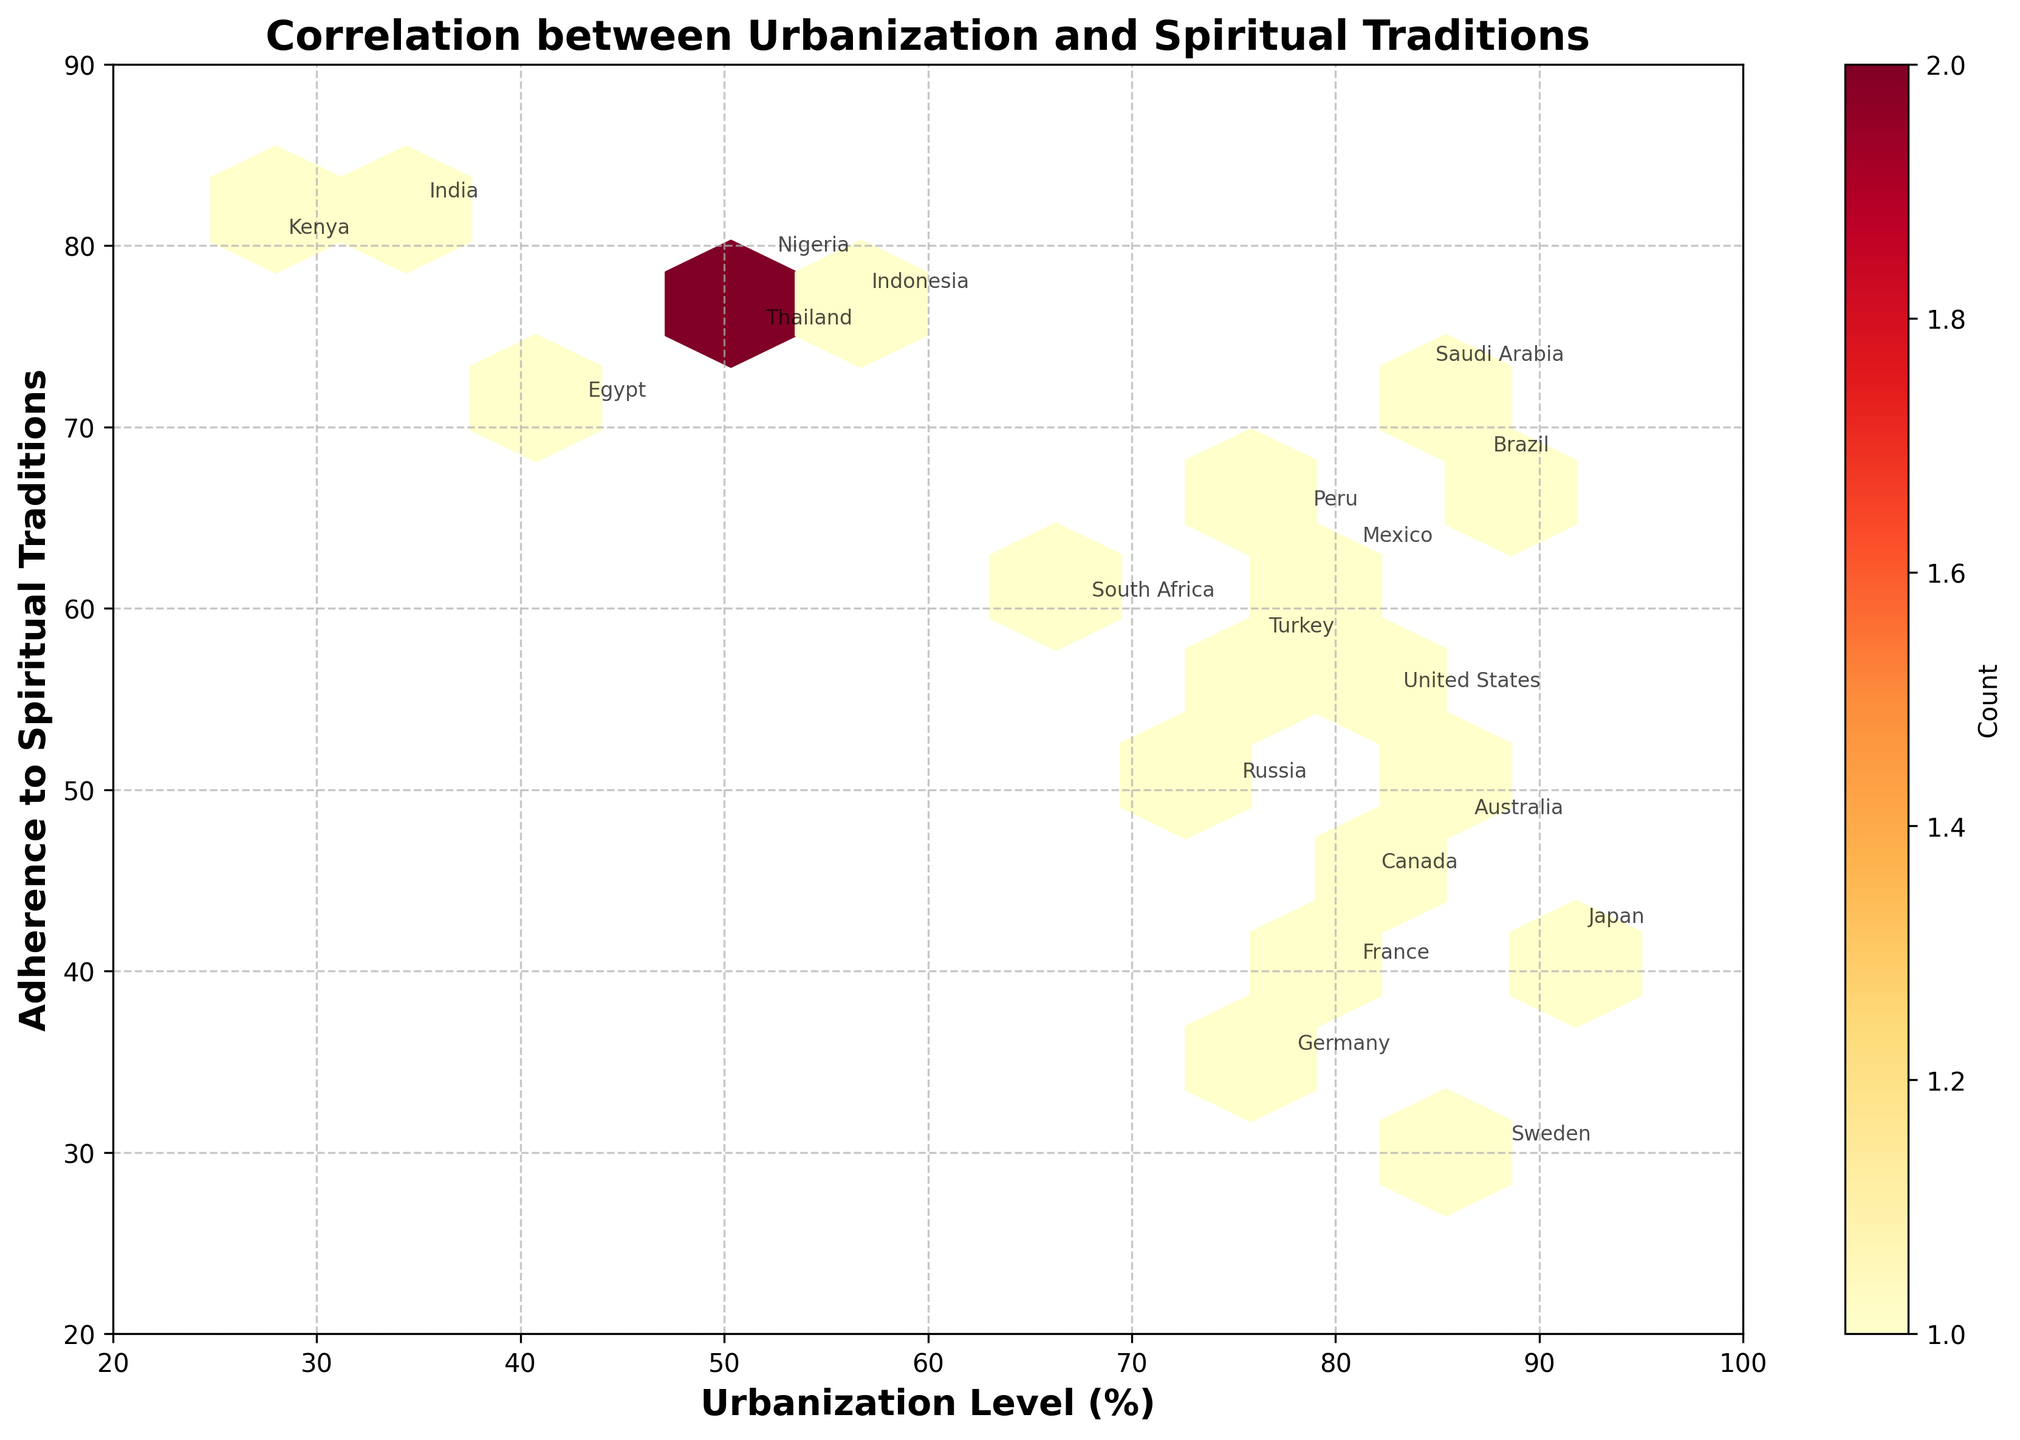What is the title of the figure? The title can be found at the top of the figure.
Answer: Correlation between Urbanization and Spiritual Traditions What are the axes labels? The labels are usually found next to the axes. The x-axis label is at the bottom and the y-axis label is to the left.
Answer: Urbanization Level (%) and Adherence to Spiritual Traditions Which country has the highest adherence to spiritual traditions? By examining the highest value on the y-axis (Adherence to Spiritual Traditions) and looking for the country annotation at that point.
Answer: India What is the range of urbanization levels presented in the figure? The x-axis starts from 20 to 100, representing the range of urbanization levels shown in the figure.
Answer: 20% to 100% How many countries have urbanization levels above 80%? By looking at the x-axis and counting the annotated countries above 80% mark.
Answer: 11 What is the trend between urbanization levels and adherence to spiritual traditions in the plot? By observing the general direction or pattern of the hexagons, one can see if there is an increase or decrease in adherence to spiritual traditions as urbanization levels change.
Answer: Negative correlation Which country represents outliers in adherence to spiritual traditions versus urbanization level, if any? Outliers can be identified by their significant deviation from the general trend or by isolated locations in the plot.
Answer: Kenya (high adherence but low urbanization) How does the clustering of hexagons help in analyzing patterns between variables? Clustering shows concentrations of data points, indicating common levels of urbanization and adherence to spiritual traditions.
Answer: Shows common patterns and concentrations Which countries have both high urbanization levels and high adherence to spiritual traditions? By identifying points in the upper right area of the plot (high on both axes).
Answer: Saudi Arabia and Brazil Do any countries have similar levels of urbanization and adherence to spiritual traditions? By finding closely located annotated points, such as Mexico and Turkey or Peru and Turkey.
Answer: Yes, Mexico and Turkey 